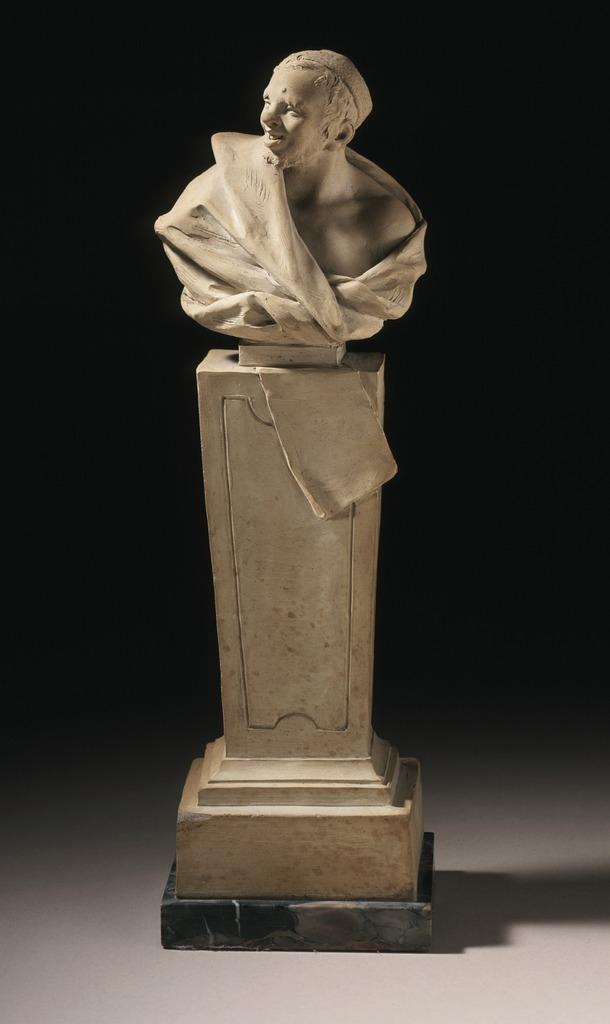What is the main subject of the image? There is a statue in the image. What can be observed about the background of the image? The background of the image is dark. Can you tell me how many birds are in the image, and how they stop to rest? There is no mention of birds or any need to stop in the image; it features a statue with a dark background. 